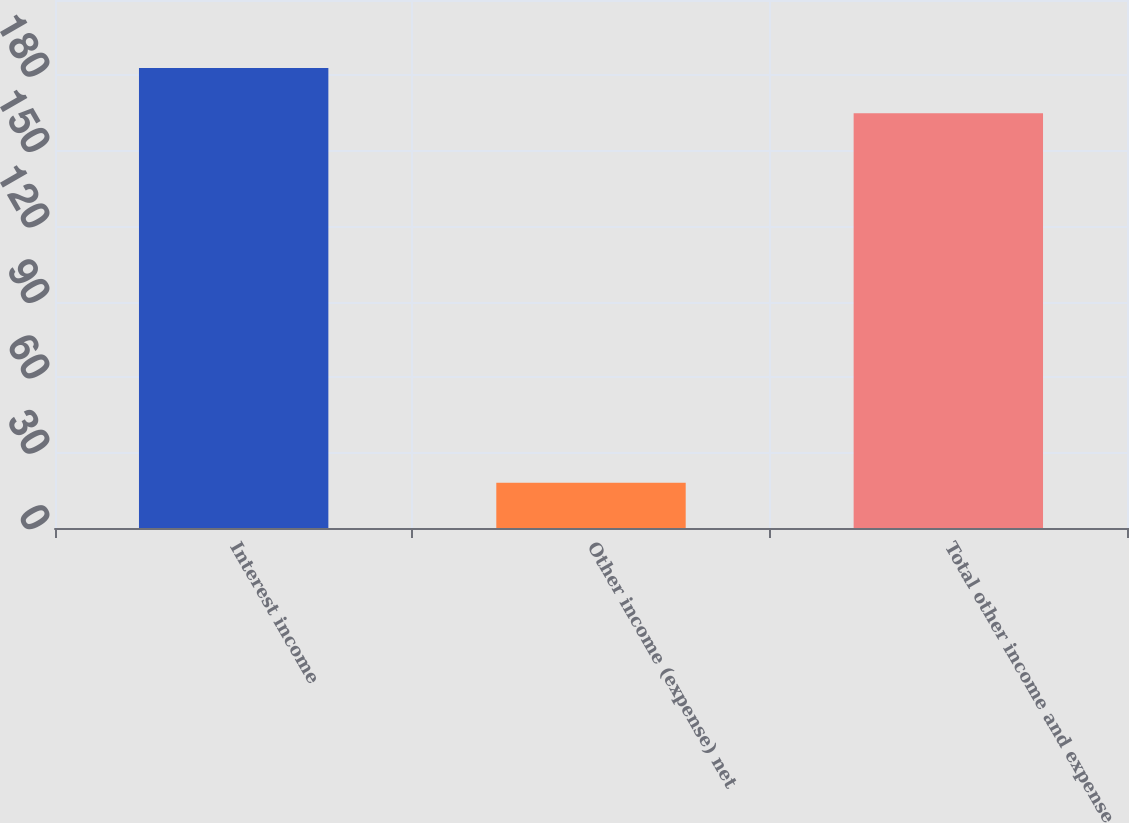Convert chart. <chart><loc_0><loc_0><loc_500><loc_500><bar_chart><fcel>Interest income<fcel>Other income (expense) net<fcel>Total other income and expense<nl><fcel>183<fcel>18<fcel>165<nl></chart> 